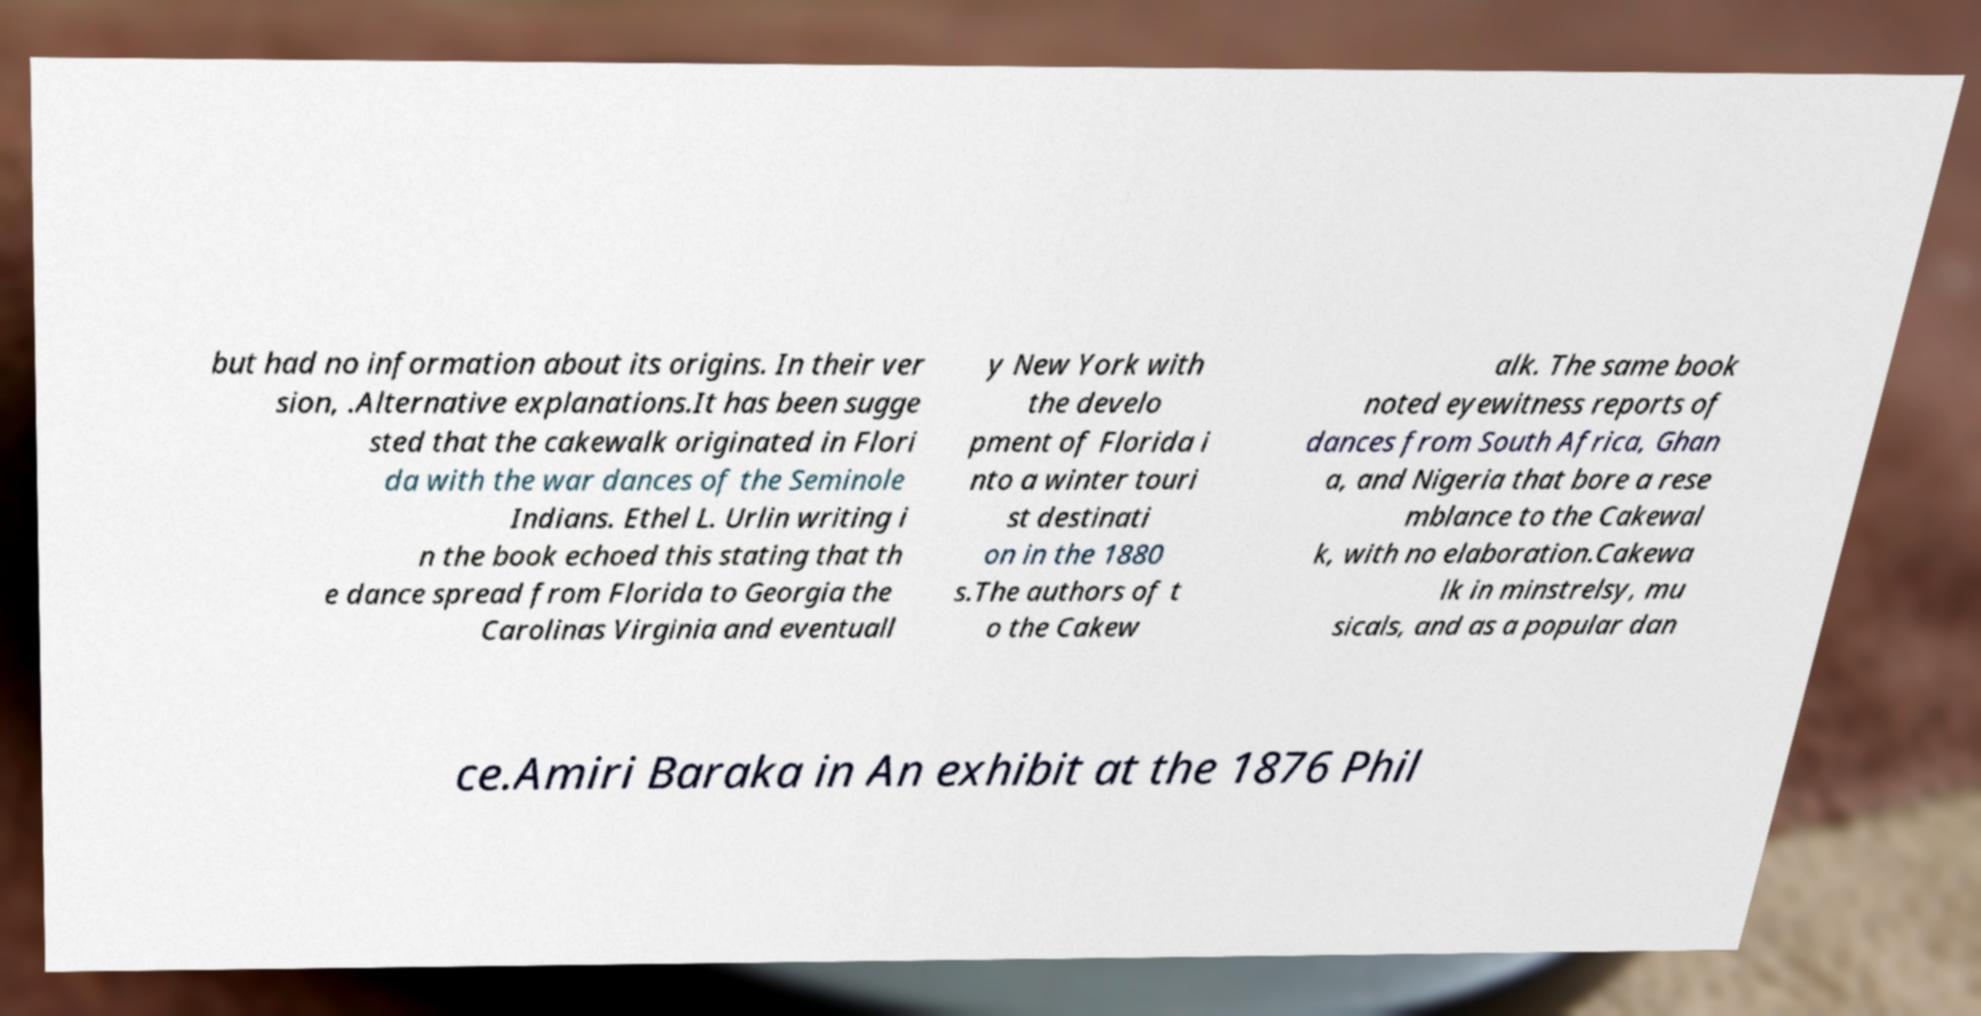What messages or text are displayed in this image? I need them in a readable, typed format. but had no information about its origins. In their ver sion, .Alternative explanations.It has been sugge sted that the cakewalk originated in Flori da with the war dances of the Seminole Indians. Ethel L. Urlin writing i n the book echoed this stating that th e dance spread from Florida to Georgia the Carolinas Virginia and eventuall y New York with the develo pment of Florida i nto a winter touri st destinati on in the 1880 s.The authors of t o the Cakew alk. The same book noted eyewitness reports of dances from South Africa, Ghan a, and Nigeria that bore a rese mblance to the Cakewal k, with no elaboration.Cakewa lk in minstrelsy, mu sicals, and as a popular dan ce.Amiri Baraka in An exhibit at the 1876 Phil 